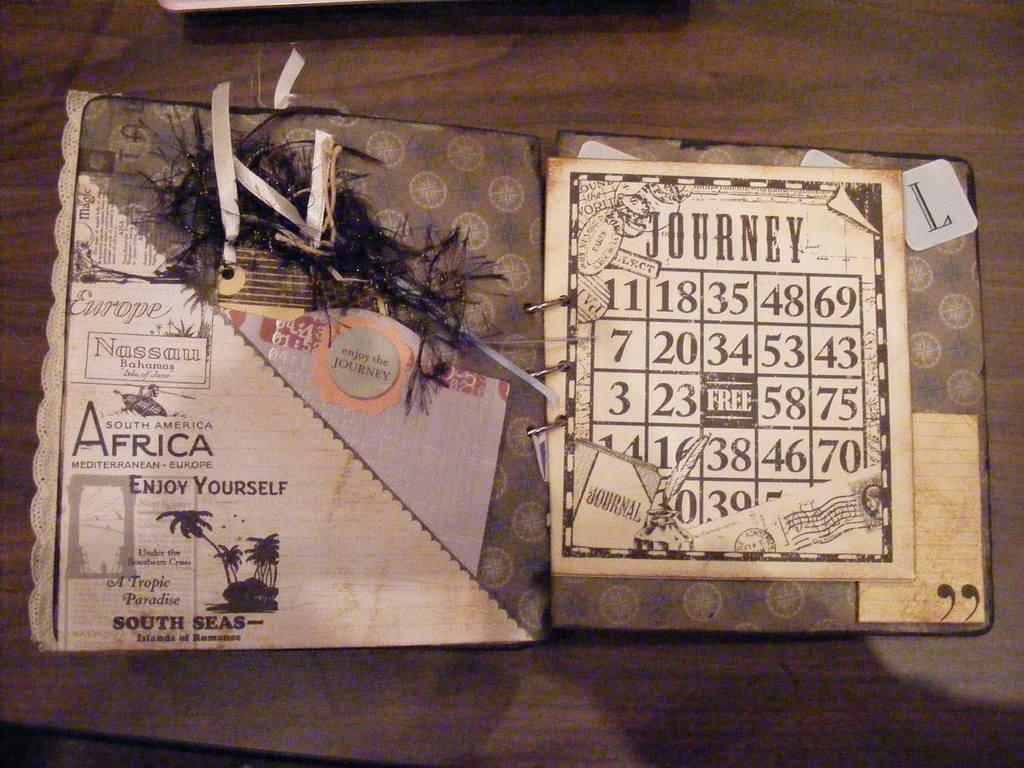<image>
Describe the image concisely. Journey bingo card with a free sign in the middle. 